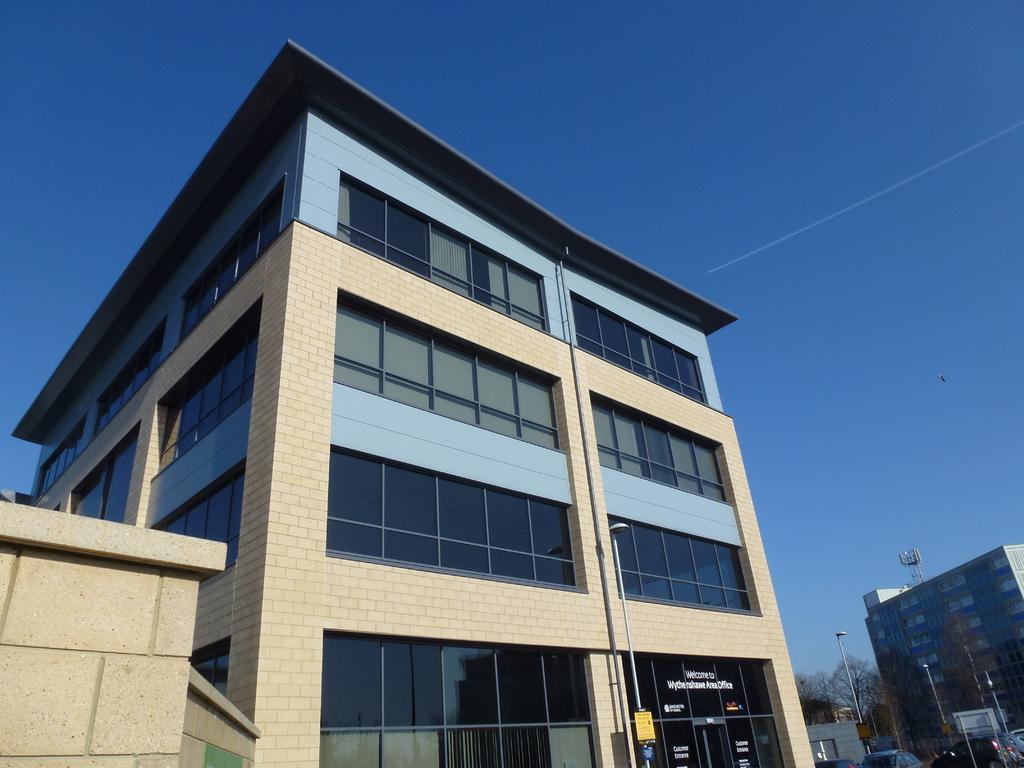In one or two sentences, can you explain what this image depicts? This picture might be taken outside of the building. In this image, on the left side corner, we can see a wall. In the middle of the image, there is a building, street lights. On the right corner, we can see a building, trees, cars, street lights. On the top there is a sky and a racket which is in air. 